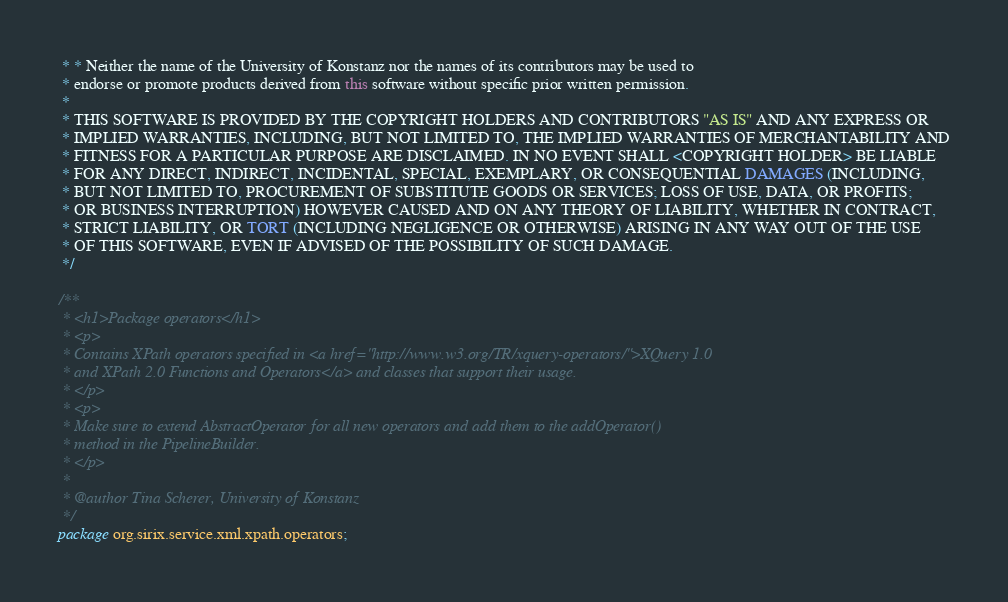<code> <loc_0><loc_0><loc_500><loc_500><_Java_> * * Neither the name of the University of Konstanz nor the names of its contributors may be used to
 * endorse or promote products derived from this software without specific prior written permission.
 * 
 * THIS SOFTWARE IS PROVIDED BY THE COPYRIGHT HOLDERS AND CONTRIBUTORS "AS IS" AND ANY EXPRESS OR
 * IMPLIED WARRANTIES, INCLUDING, BUT NOT LIMITED TO, THE IMPLIED WARRANTIES OF MERCHANTABILITY AND
 * FITNESS FOR A PARTICULAR PURPOSE ARE DISCLAIMED. IN NO EVENT SHALL <COPYRIGHT HOLDER> BE LIABLE
 * FOR ANY DIRECT, INDIRECT, INCIDENTAL, SPECIAL, EXEMPLARY, OR CONSEQUENTIAL DAMAGES (INCLUDING,
 * BUT NOT LIMITED TO, PROCUREMENT OF SUBSTITUTE GOODS OR SERVICES; LOSS OF USE, DATA, OR PROFITS;
 * OR BUSINESS INTERRUPTION) HOWEVER CAUSED AND ON ANY THEORY OF LIABILITY, WHETHER IN CONTRACT,
 * STRICT LIABILITY, OR TORT (INCLUDING NEGLIGENCE OR OTHERWISE) ARISING IN ANY WAY OUT OF THE USE
 * OF THIS SOFTWARE, EVEN IF ADVISED OF THE POSSIBILITY OF SUCH DAMAGE.
 */

/**
 * <h1>Package operators</h1>
 * <p>
 * Contains XPath operators specified in <a href="http://www.w3.org/TR/xquery-operators/">XQuery 1.0
 * and XPath 2.0 Functions and Operators</a> and classes that support their usage.
 * </p>
 * <p>
 * Make sure to extend AbstractOperator for all new operators and add them to the addOperator()
 * method in the PipelineBuilder.
 * </p>
 * 
 * @author Tina Scherer, University of Konstanz
 */
package org.sirix.service.xml.xpath.operators;

</code> 